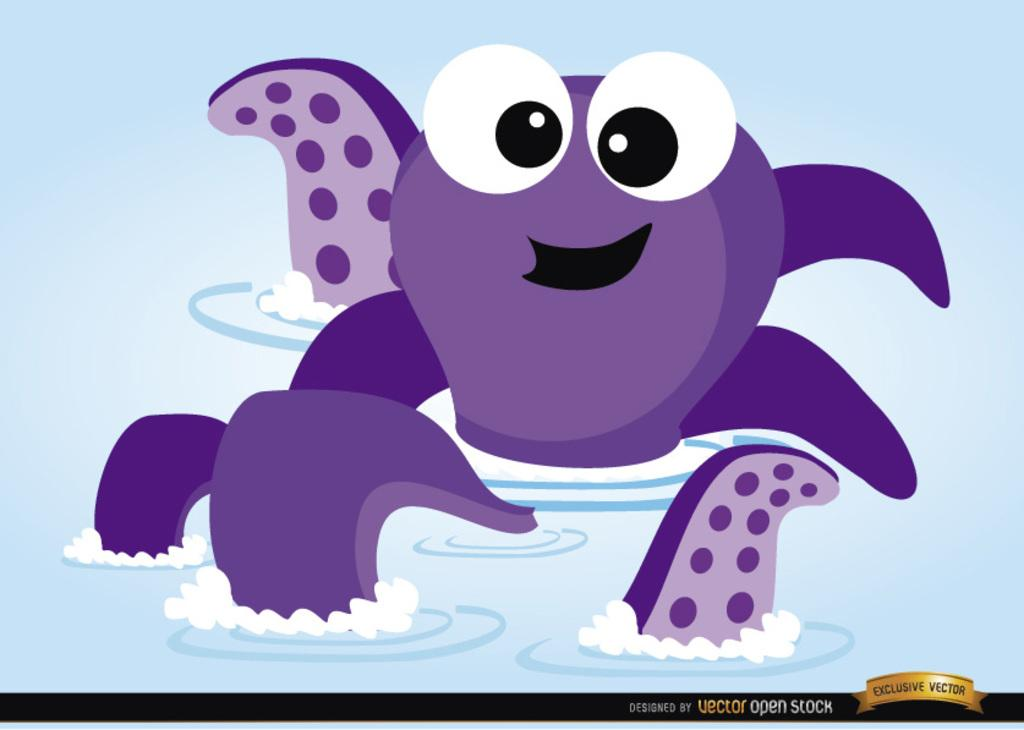What type of objects are present in the image? There are vector open stock animals in the image. Where are the animals located? The animals are on the water. What type of stew is being prepared by the crowd in the image? There is no crowd or stew present in the image; it only features vector open stock animals on the water. 